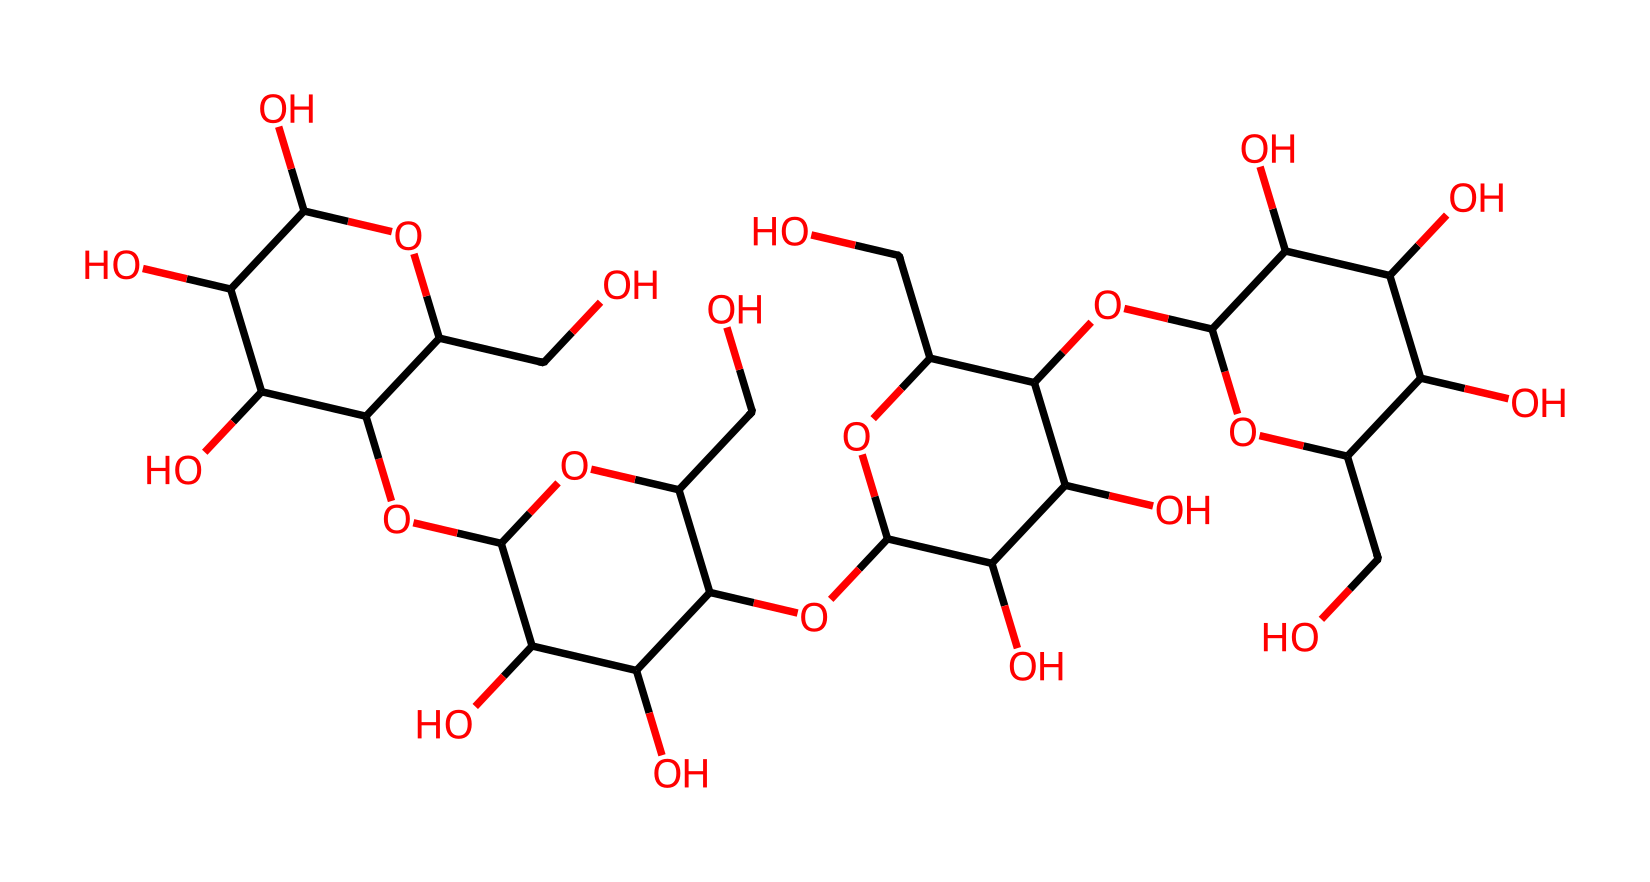What is the main structural component of the chemical? The chemical given in the SMILES representation corresponds to cellulose, which is a polysaccharide made up of β-D-glucose units linked by β(1→4) glycosidic bonds. Its structure features long chains of glucose monomers.
Answer: cellulose How many hydroxyl (OH) groups are present in the molecule? By analyzing the structure derived from the SMILES representation, there are multiple oxygen atoms that appear as hydroxyl groups (OH). Counting each oxygen atom bonded to a carbon atom as a hydroxyl group, we find a total of 8.
Answer: 8 What type of bonding is primarily responsible for the structural integrity of cellulose? The structural integrity of cellulose arises mainly from hydrogen bonding between the hydroxyl groups of adjacent cellulose chains, which allows for strong intermolecular interactions.
Answer: hydrogen bonding What is the degree of polymerization indicated by the structure? The structure shows several repeating units of glucose, indicating a significant degree of polymerization typical for cellulose, which can exceed several thousand glucose monomers. For this question, we'll consider the repeating unit approach, leading us to approximately 6 repeating units visible in the SMILES notation.
Answer: 6 What role does this fiber play in plant cells? Cellulose serves a crucial role in providing structural support to plant cell walls, contributing to the rigidity and strength necessary for maintaining plant shape and resisting external pressures.
Answer: structural support What characteristic of cellulose enables it to form strong fibers? The extensive hydrogen bonding between adjacent cellulose chains allows cellulose to aggregate into crystalline structures, which enhances the tensile strength and durability of plant fibers.
Answer: hydrogen bonding 